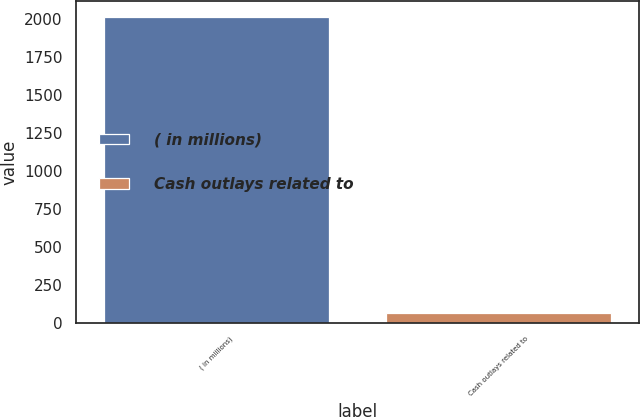Convert chart. <chart><loc_0><loc_0><loc_500><loc_500><bar_chart><fcel>( in millions)<fcel>Cash outlays related to<nl><fcel>2018<fcel>64<nl></chart> 